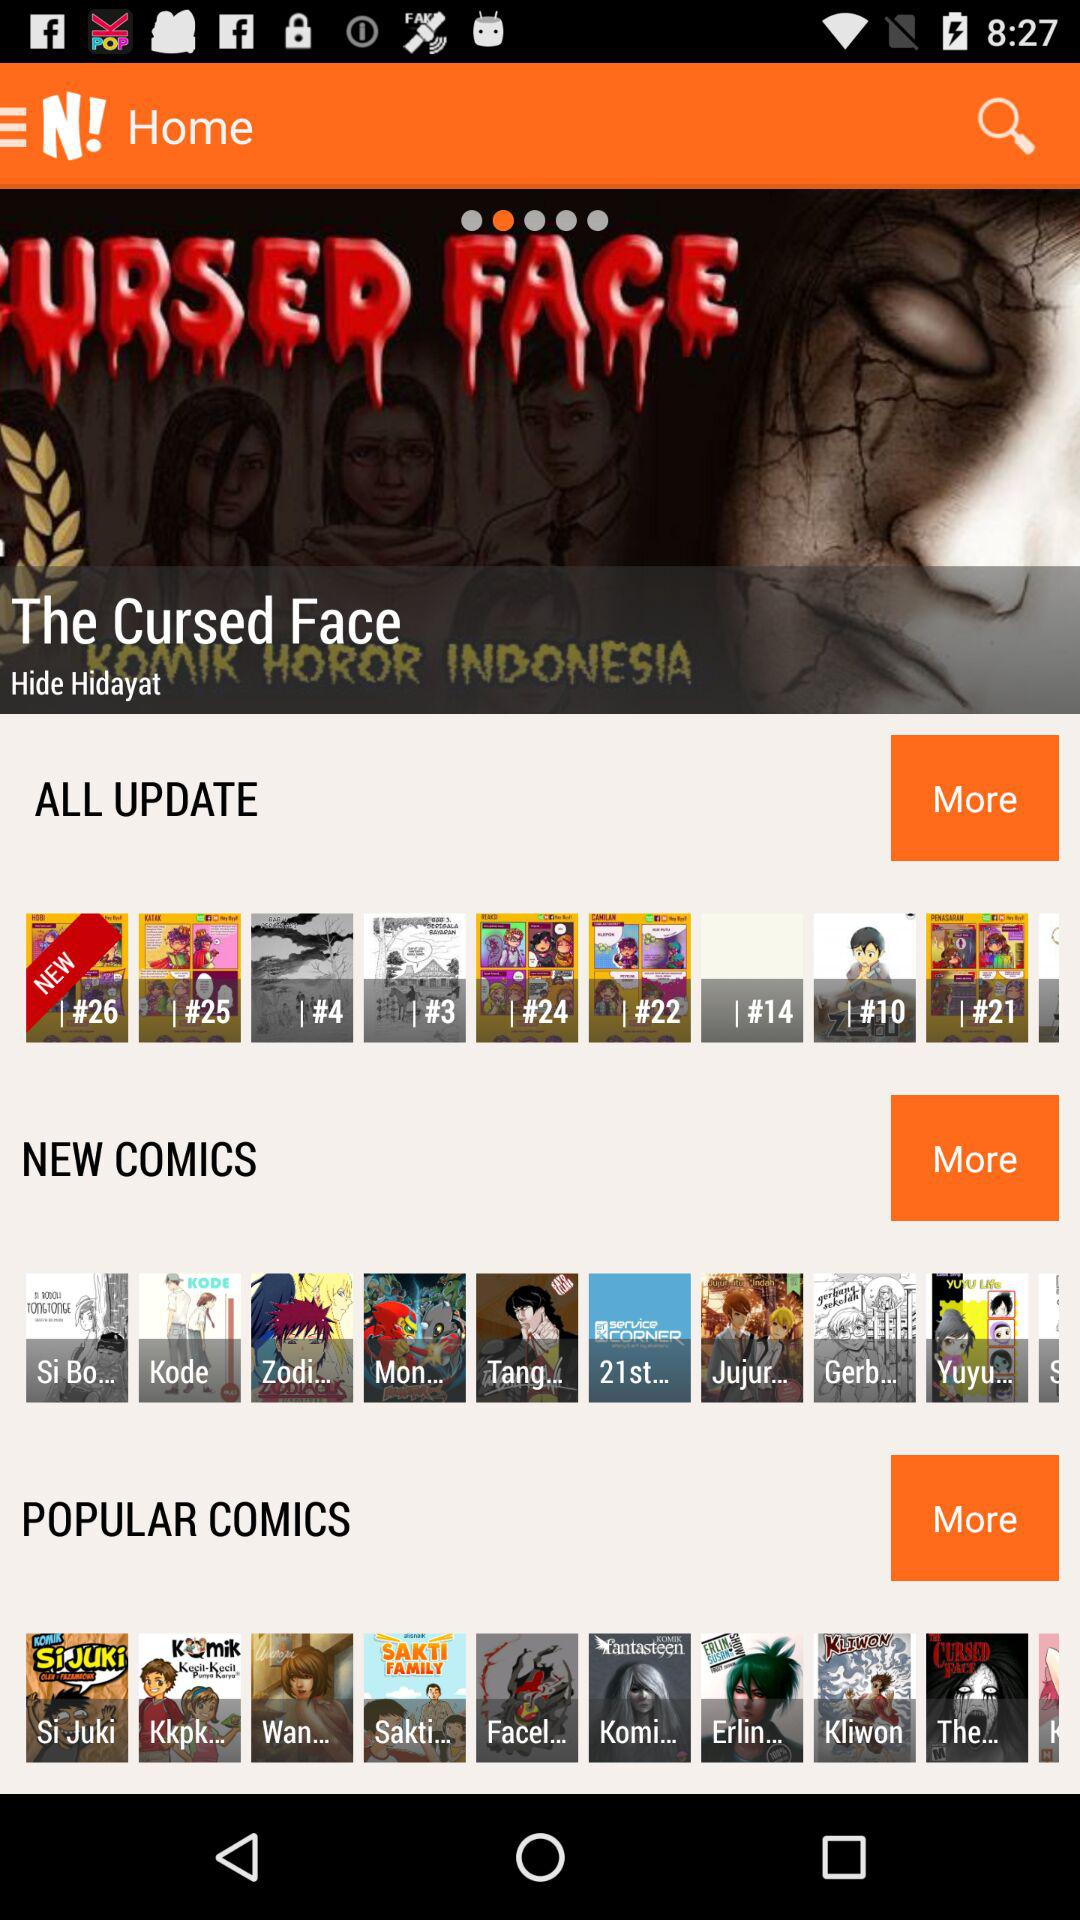Who is the author of the comic "The Cursed Face"? The author of the comic "The Cursed Face" is Hide Hidayat. 